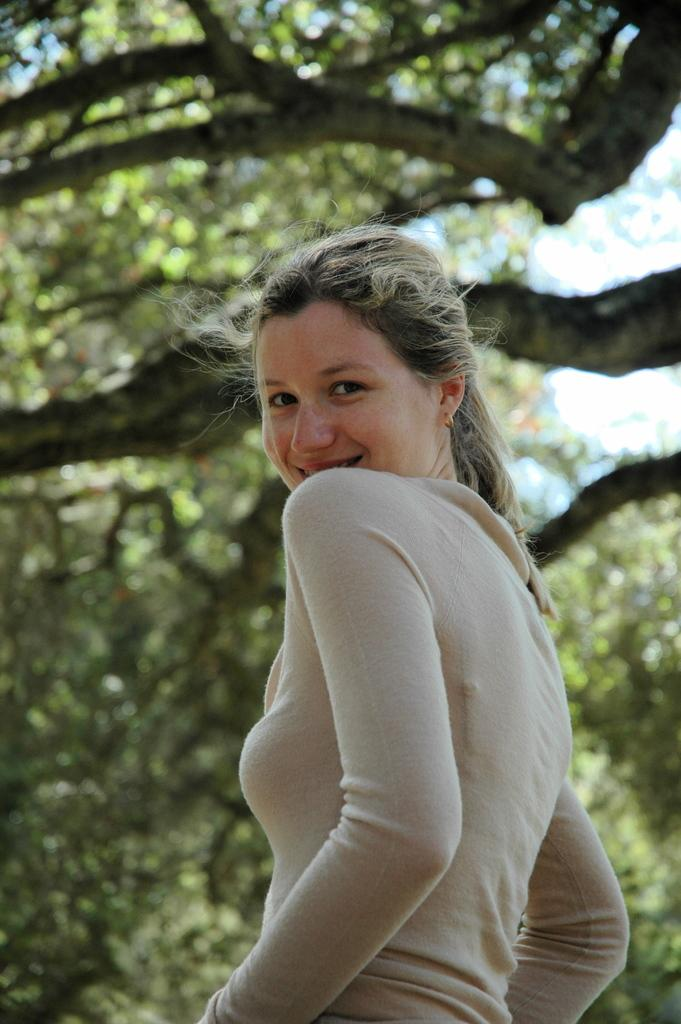What is the main subject of the image? There is a woman standing in the image. What can be seen in the background of the image? There are trees and the sky visible in the background of the image. How does the beggar try to trick the lock in the image? There is no beggar or lock present in the image. What type of trick is the woman performing on the lock in the image? There is no trick or lock present in the image; the woman is simply standing. 